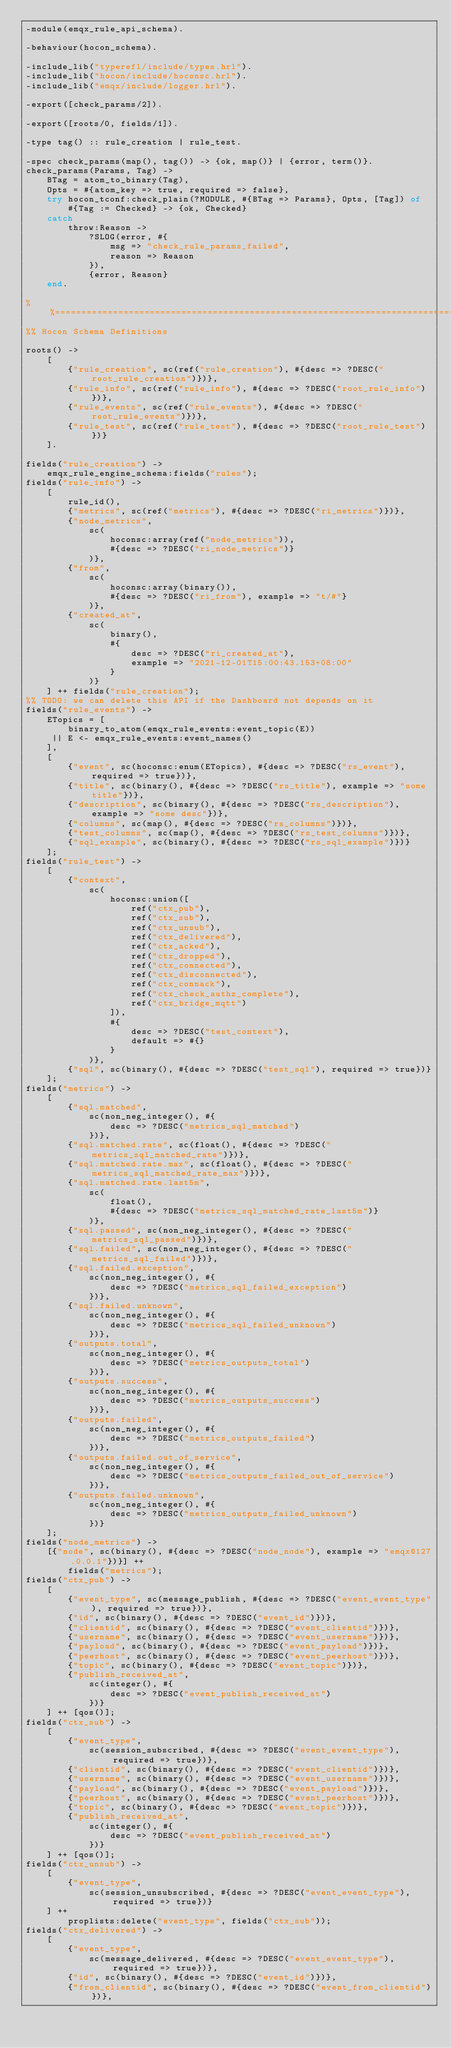Convert code to text. <code><loc_0><loc_0><loc_500><loc_500><_Erlang_>-module(emqx_rule_api_schema).

-behaviour(hocon_schema).

-include_lib("typerefl/include/types.hrl").
-include_lib("hocon/include/hoconsc.hrl").
-include_lib("emqx/include/logger.hrl").

-export([check_params/2]).

-export([roots/0, fields/1]).

-type tag() :: rule_creation | rule_test.

-spec check_params(map(), tag()) -> {ok, map()} | {error, term()}.
check_params(Params, Tag) ->
    BTag = atom_to_binary(Tag),
    Opts = #{atom_key => true, required => false},
    try hocon_tconf:check_plain(?MODULE, #{BTag => Params}, Opts, [Tag]) of
        #{Tag := Checked} -> {ok, Checked}
    catch
        throw:Reason ->
            ?SLOG(error, #{
                msg => "check_rule_params_failed",
                reason => Reason
            }),
            {error, Reason}
    end.

%%======================================================================================
%% Hocon Schema Definitions

roots() ->
    [
        {"rule_creation", sc(ref("rule_creation"), #{desc => ?DESC("root_rule_creation")})},
        {"rule_info", sc(ref("rule_info"), #{desc => ?DESC("root_rule_info")})},
        {"rule_events", sc(ref("rule_events"), #{desc => ?DESC("root_rule_events")})},
        {"rule_test", sc(ref("rule_test"), #{desc => ?DESC("root_rule_test")})}
    ].

fields("rule_creation") ->
    emqx_rule_engine_schema:fields("rules");
fields("rule_info") ->
    [
        rule_id(),
        {"metrics", sc(ref("metrics"), #{desc => ?DESC("ri_metrics")})},
        {"node_metrics",
            sc(
                hoconsc:array(ref("node_metrics")),
                #{desc => ?DESC("ri_node_metrics")}
            )},
        {"from",
            sc(
                hoconsc:array(binary()),
                #{desc => ?DESC("ri_from"), example => "t/#"}
            )},
        {"created_at",
            sc(
                binary(),
                #{
                    desc => ?DESC("ri_created_at"),
                    example => "2021-12-01T15:00:43.153+08:00"
                }
            )}
    ] ++ fields("rule_creation");
%% TODO: we can delete this API if the Dashboard not depends on it
fields("rule_events") ->
    ETopics = [
        binary_to_atom(emqx_rule_events:event_topic(E))
     || E <- emqx_rule_events:event_names()
    ],
    [
        {"event", sc(hoconsc:enum(ETopics), #{desc => ?DESC("rs_event"), required => true})},
        {"title", sc(binary(), #{desc => ?DESC("rs_title"), example => "some title"})},
        {"description", sc(binary(), #{desc => ?DESC("rs_description"), example => "some desc"})},
        {"columns", sc(map(), #{desc => ?DESC("rs_columns")})},
        {"test_columns", sc(map(), #{desc => ?DESC("rs_test_columns")})},
        {"sql_example", sc(binary(), #{desc => ?DESC("rs_sql_example")})}
    ];
fields("rule_test") ->
    [
        {"context",
            sc(
                hoconsc:union([
                    ref("ctx_pub"),
                    ref("ctx_sub"),
                    ref("ctx_unsub"),
                    ref("ctx_delivered"),
                    ref("ctx_acked"),
                    ref("ctx_dropped"),
                    ref("ctx_connected"),
                    ref("ctx_disconnected"),
                    ref("ctx_connack"),
                    ref("ctx_check_authz_complete"),
                    ref("ctx_bridge_mqtt")
                ]),
                #{
                    desc => ?DESC("test_context"),
                    default => #{}
                }
            )},
        {"sql", sc(binary(), #{desc => ?DESC("test_sql"), required => true})}
    ];
fields("metrics") ->
    [
        {"sql.matched",
            sc(non_neg_integer(), #{
                desc => ?DESC("metrics_sql_matched")
            })},
        {"sql.matched.rate", sc(float(), #{desc => ?DESC("metrics_sql_matched_rate")})},
        {"sql.matched.rate.max", sc(float(), #{desc => ?DESC("metrics_sql_matched_rate_max")})},
        {"sql.matched.rate.last5m",
            sc(
                float(),
                #{desc => ?DESC("metrics_sql_matched_rate_last5m")}
            )},
        {"sql.passed", sc(non_neg_integer(), #{desc => ?DESC("metrics_sql_passed")})},
        {"sql.failed", sc(non_neg_integer(), #{desc => ?DESC("metrics_sql_failed")})},
        {"sql.failed.exception",
            sc(non_neg_integer(), #{
                desc => ?DESC("metrics_sql_failed_exception")
            })},
        {"sql.failed.unknown",
            sc(non_neg_integer(), #{
                desc => ?DESC("metrics_sql_failed_unknown")
            })},
        {"outputs.total",
            sc(non_neg_integer(), #{
                desc => ?DESC("metrics_outputs_total")
            })},
        {"outputs.success",
            sc(non_neg_integer(), #{
                desc => ?DESC("metrics_outputs_success")
            })},
        {"outputs.failed",
            sc(non_neg_integer(), #{
                desc => ?DESC("metrics_outputs_failed")
            })},
        {"outputs.failed.out_of_service",
            sc(non_neg_integer(), #{
                desc => ?DESC("metrics_outputs_failed_out_of_service")
            })},
        {"outputs.failed.unknown",
            sc(non_neg_integer(), #{
                desc => ?DESC("metrics_outputs_failed_unknown")
            })}
    ];
fields("node_metrics") ->
    [{"node", sc(binary(), #{desc => ?DESC("node_node"), example => "emqx@127.0.0.1"})}] ++
        fields("metrics");
fields("ctx_pub") ->
    [
        {"event_type", sc(message_publish, #{desc => ?DESC("event_event_type"), required => true})},
        {"id", sc(binary(), #{desc => ?DESC("event_id")})},
        {"clientid", sc(binary(), #{desc => ?DESC("event_clientid")})},
        {"username", sc(binary(), #{desc => ?DESC("event_username")})},
        {"payload", sc(binary(), #{desc => ?DESC("event_payload")})},
        {"peerhost", sc(binary(), #{desc => ?DESC("event_peerhost")})},
        {"topic", sc(binary(), #{desc => ?DESC("event_topic")})},
        {"publish_received_at",
            sc(integer(), #{
                desc => ?DESC("event_publish_received_at")
            })}
    ] ++ [qos()];
fields("ctx_sub") ->
    [
        {"event_type",
            sc(session_subscribed, #{desc => ?DESC("event_event_type"), required => true})},
        {"clientid", sc(binary(), #{desc => ?DESC("event_clientid")})},
        {"username", sc(binary(), #{desc => ?DESC("event_username")})},
        {"payload", sc(binary(), #{desc => ?DESC("event_payload")})},
        {"peerhost", sc(binary(), #{desc => ?DESC("event_peerhost")})},
        {"topic", sc(binary(), #{desc => ?DESC("event_topic")})},
        {"publish_received_at",
            sc(integer(), #{
                desc => ?DESC("event_publish_received_at")
            })}
    ] ++ [qos()];
fields("ctx_unsub") ->
    [
        {"event_type",
            sc(session_unsubscribed, #{desc => ?DESC("event_event_type"), required => true})}
    ] ++
        proplists:delete("event_type", fields("ctx_sub"));
fields("ctx_delivered") ->
    [
        {"event_type",
            sc(message_delivered, #{desc => ?DESC("event_event_type"), required => true})},
        {"id", sc(binary(), #{desc => ?DESC("event_id")})},
        {"from_clientid", sc(binary(), #{desc => ?DESC("event_from_clientid")})},</code> 